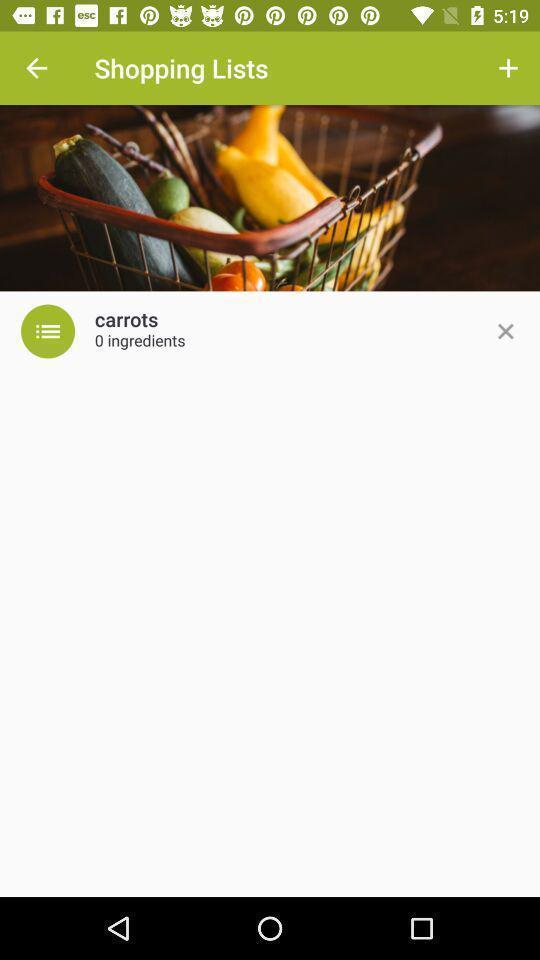Summarize the main components in this picture. Page showing an image of a fruit basket. 